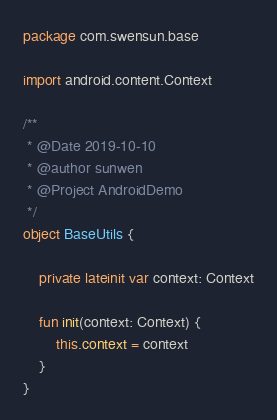<code> <loc_0><loc_0><loc_500><loc_500><_Kotlin_>package com.swensun.base

import android.content.Context

/**
 * @Date 2019-10-10
 * @author sunwen
 * @Project AndroidDemo
 */
object BaseUtils {

    private lateinit var context: Context

    fun init(context: Context) {
        this.context = context
    }
}</code> 